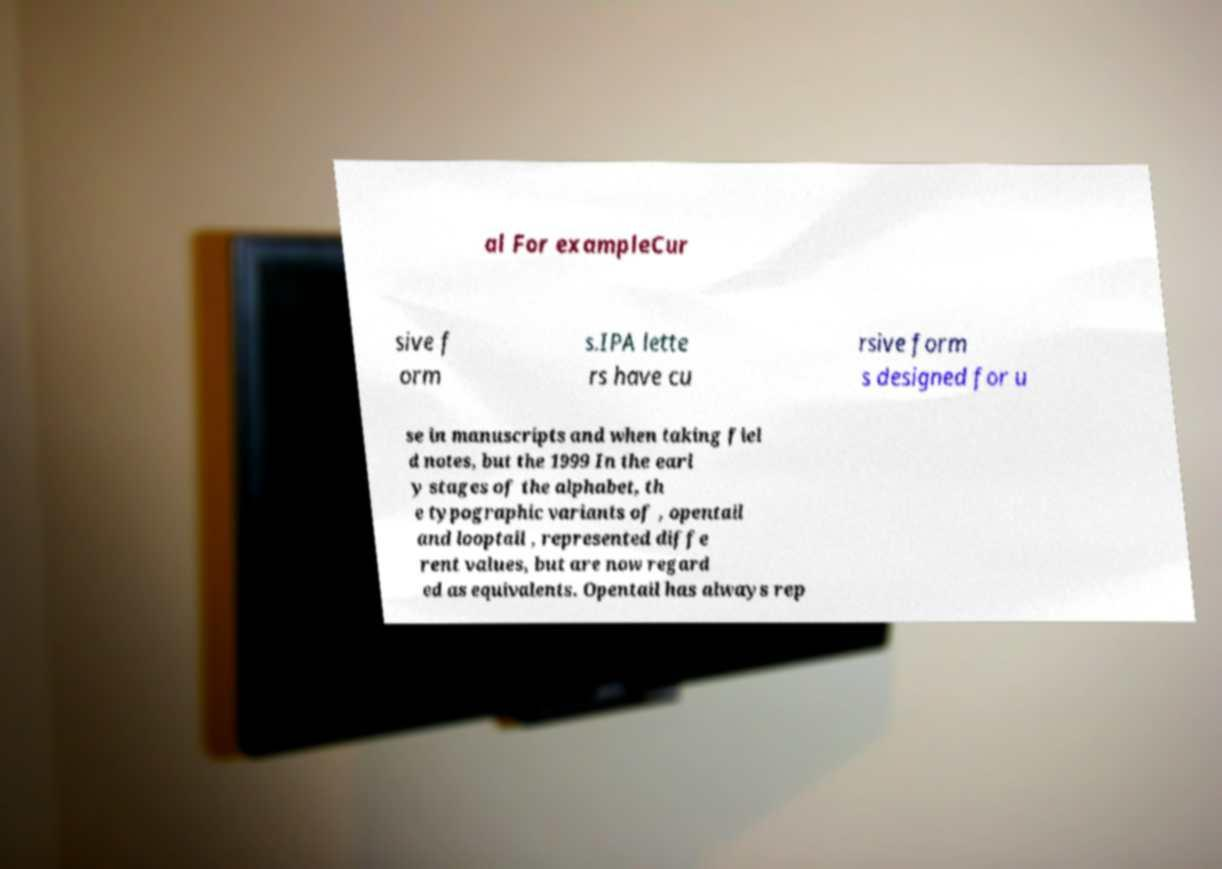Can you read and provide the text displayed in the image?This photo seems to have some interesting text. Can you extract and type it out for me? al For exampleCur sive f orm s.IPA lette rs have cu rsive form s designed for u se in manuscripts and when taking fiel d notes, but the 1999 In the earl y stages of the alphabet, th e typographic variants of , opentail and looptail , represented diffe rent values, but are now regard ed as equivalents. Opentail has always rep 